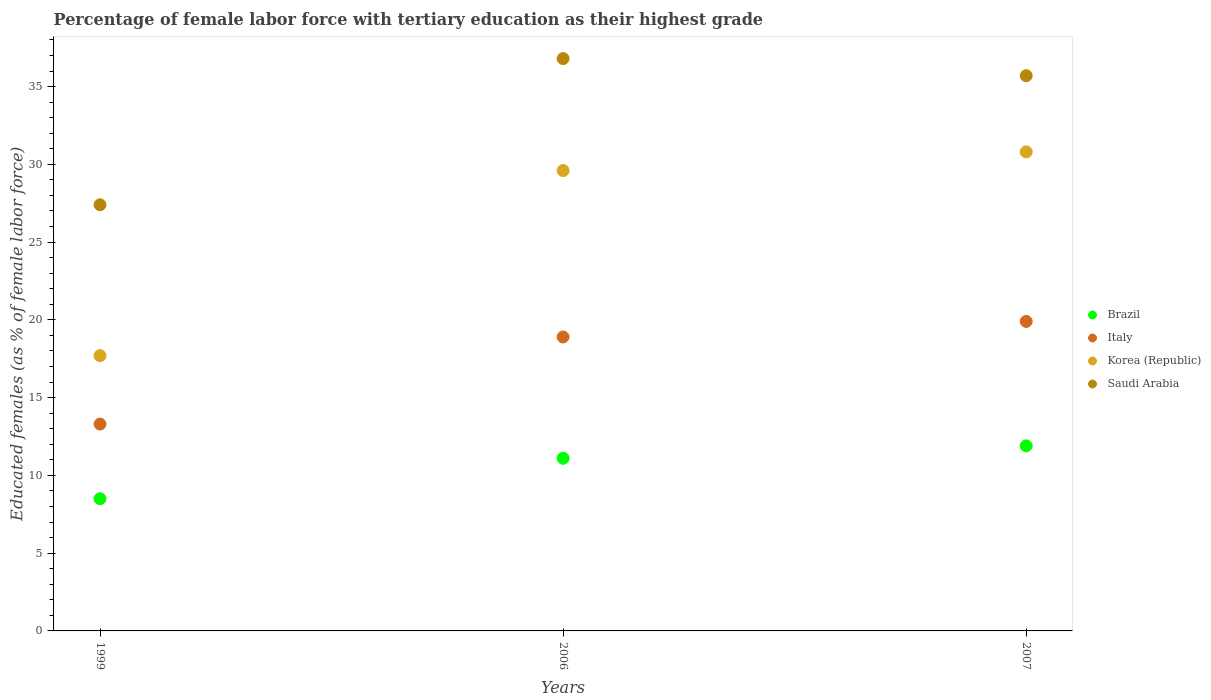How many different coloured dotlines are there?
Offer a terse response. 4. What is the percentage of female labor force with tertiary education in Korea (Republic) in 2007?
Keep it short and to the point. 30.8. Across all years, what is the maximum percentage of female labor force with tertiary education in Saudi Arabia?
Your answer should be compact. 36.8. Across all years, what is the minimum percentage of female labor force with tertiary education in Italy?
Offer a terse response. 13.3. In which year was the percentage of female labor force with tertiary education in Italy maximum?
Your response must be concise. 2007. In which year was the percentage of female labor force with tertiary education in Saudi Arabia minimum?
Offer a terse response. 1999. What is the total percentage of female labor force with tertiary education in Saudi Arabia in the graph?
Offer a very short reply. 99.9. What is the difference between the percentage of female labor force with tertiary education in Brazil in 1999 and that in 2007?
Provide a succinct answer. -3.4. What is the difference between the percentage of female labor force with tertiary education in Saudi Arabia in 1999 and the percentage of female labor force with tertiary education in Brazil in 2007?
Ensure brevity in your answer.  15.5. What is the average percentage of female labor force with tertiary education in Italy per year?
Provide a succinct answer. 17.37. In the year 2006, what is the difference between the percentage of female labor force with tertiary education in Korea (Republic) and percentage of female labor force with tertiary education in Brazil?
Provide a succinct answer. 18.5. In how many years, is the percentage of female labor force with tertiary education in Saudi Arabia greater than 4 %?
Keep it short and to the point. 3. What is the ratio of the percentage of female labor force with tertiary education in Italy in 2006 to that in 2007?
Offer a terse response. 0.95. Is the percentage of female labor force with tertiary education in Italy in 2006 less than that in 2007?
Your answer should be compact. Yes. What is the difference between the highest and the second highest percentage of female labor force with tertiary education in Saudi Arabia?
Ensure brevity in your answer.  1.1. What is the difference between the highest and the lowest percentage of female labor force with tertiary education in Korea (Republic)?
Provide a short and direct response. 13.1. In how many years, is the percentage of female labor force with tertiary education in Italy greater than the average percentage of female labor force with tertiary education in Italy taken over all years?
Your response must be concise. 2. Is the sum of the percentage of female labor force with tertiary education in Italy in 2006 and 2007 greater than the maximum percentage of female labor force with tertiary education in Saudi Arabia across all years?
Provide a succinct answer. Yes. Is it the case that in every year, the sum of the percentage of female labor force with tertiary education in Saudi Arabia and percentage of female labor force with tertiary education in Brazil  is greater than the sum of percentage of female labor force with tertiary education in Korea (Republic) and percentage of female labor force with tertiary education in Italy?
Give a very brief answer. Yes. Does the percentage of female labor force with tertiary education in Saudi Arabia monotonically increase over the years?
Keep it short and to the point. No. Is the percentage of female labor force with tertiary education in Korea (Republic) strictly greater than the percentage of female labor force with tertiary education in Saudi Arabia over the years?
Keep it short and to the point. No. Is the percentage of female labor force with tertiary education in Korea (Republic) strictly less than the percentage of female labor force with tertiary education in Italy over the years?
Your response must be concise. No. What is the title of the graph?
Your response must be concise. Percentage of female labor force with tertiary education as their highest grade. What is the label or title of the Y-axis?
Offer a terse response. Educated females (as % of female labor force). What is the Educated females (as % of female labor force) of Italy in 1999?
Keep it short and to the point. 13.3. What is the Educated females (as % of female labor force) in Korea (Republic) in 1999?
Provide a succinct answer. 17.7. What is the Educated females (as % of female labor force) of Saudi Arabia in 1999?
Provide a short and direct response. 27.4. What is the Educated females (as % of female labor force) in Brazil in 2006?
Your answer should be compact. 11.1. What is the Educated females (as % of female labor force) of Italy in 2006?
Provide a succinct answer. 18.9. What is the Educated females (as % of female labor force) in Korea (Republic) in 2006?
Provide a short and direct response. 29.6. What is the Educated females (as % of female labor force) in Saudi Arabia in 2006?
Your answer should be compact. 36.8. What is the Educated females (as % of female labor force) in Brazil in 2007?
Offer a terse response. 11.9. What is the Educated females (as % of female labor force) of Italy in 2007?
Ensure brevity in your answer.  19.9. What is the Educated females (as % of female labor force) in Korea (Republic) in 2007?
Give a very brief answer. 30.8. What is the Educated females (as % of female labor force) of Saudi Arabia in 2007?
Offer a terse response. 35.7. Across all years, what is the maximum Educated females (as % of female labor force) of Brazil?
Your answer should be very brief. 11.9. Across all years, what is the maximum Educated females (as % of female labor force) of Italy?
Offer a very short reply. 19.9. Across all years, what is the maximum Educated females (as % of female labor force) in Korea (Republic)?
Keep it short and to the point. 30.8. Across all years, what is the maximum Educated females (as % of female labor force) of Saudi Arabia?
Your answer should be very brief. 36.8. Across all years, what is the minimum Educated females (as % of female labor force) in Brazil?
Make the answer very short. 8.5. Across all years, what is the minimum Educated females (as % of female labor force) in Italy?
Provide a succinct answer. 13.3. Across all years, what is the minimum Educated females (as % of female labor force) of Korea (Republic)?
Make the answer very short. 17.7. Across all years, what is the minimum Educated females (as % of female labor force) of Saudi Arabia?
Your response must be concise. 27.4. What is the total Educated females (as % of female labor force) of Brazil in the graph?
Your answer should be very brief. 31.5. What is the total Educated females (as % of female labor force) in Italy in the graph?
Keep it short and to the point. 52.1. What is the total Educated females (as % of female labor force) of Korea (Republic) in the graph?
Ensure brevity in your answer.  78.1. What is the total Educated females (as % of female labor force) in Saudi Arabia in the graph?
Provide a succinct answer. 99.9. What is the difference between the Educated females (as % of female labor force) in Italy in 1999 and that in 2006?
Give a very brief answer. -5.6. What is the difference between the Educated females (as % of female labor force) of Saudi Arabia in 1999 and that in 2006?
Ensure brevity in your answer.  -9.4. What is the difference between the Educated females (as % of female labor force) in Brazil in 1999 and that in 2007?
Your answer should be compact. -3.4. What is the difference between the Educated females (as % of female labor force) in Korea (Republic) in 1999 and that in 2007?
Your response must be concise. -13.1. What is the difference between the Educated females (as % of female labor force) of Saudi Arabia in 2006 and that in 2007?
Offer a terse response. 1.1. What is the difference between the Educated females (as % of female labor force) in Brazil in 1999 and the Educated females (as % of female labor force) in Korea (Republic) in 2006?
Your answer should be very brief. -21.1. What is the difference between the Educated females (as % of female labor force) of Brazil in 1999 and the Educated females (as % of female labor force) of Saudi Arabia in 2006?
Offer a very short reply. -28.3. What is the difference between the Educated females (as % of female labor force) of Italy in 1999 and the Educated females (as % of female labor force) of Korea (Republic) in 2006?
Provide a short and direct response. -16.3. What is the difference between the Educated females (as % of female labor force) in Italy in 1999 and the Educated females (as % of female labor force) in Saudi Arabia in 2006?
Make the answer very short. -23.5. What is the difference between the Educated females (as % of female labor force) in Korea (Republic) in 1999 and the Educated females (as % of female labor force) in Saudi Arabia in 2006?
Give a very brief answer. -19.1. What is the difference between the Educated females (as % of female labor force) of Brazil in 1999 and the Educated females (as % of female labor force) of Korea (Republic) in 2007?
Give a very brief answer. -22.3. What is the difference between the Educated females (as % of female labor force) of Brazil in 1999 and the Educated females (as % of female labor force) of Saudi Arabia in 2007?
Offer a very short reply. -27.2. What is the difference between the Educated females (as % of female labor force) of Italy in 1999 and the Educated females (as % of female labor force) of Korea (Republic) in 2007?
Make the answer very short. -17.5. What is the difference between the Educated females (as % of female labor force) in Italy in 1999 and the Educated females (as % of female labor force) in Saudi Arabia in 2007?
Ensure brevity in your answer.  -22.4. What is the difference between the Educated females (as % of female labor force) of Brazil in 2006 and the Educated females (as % of female labor force) of Korea (Republic) in 2007?
Your response must be concise. -19.7. What is the difference between the Educated females (as % of female labor force) of Brazil in 2006 and the Educated females (as % of female labor force) of Saudi Arabia in 2007?
Provide a succinct answer. -24.6. What is the difference between the Educated females (as % of female labor force) in Italy in 2006 and the Educated females (as % of female labor force) in Saudi Arabia in 2007?
Provide a succinct answer. -16.8. What is the average Educated females (as % of female labor force) of Brazil per year?
Keep it short and to the point. 10.5. What is the average Educated females (as % of female labor force) in Italy per year?
Give a very brief answer. 17.37. What is the average Educated females (as % of female labor force) of Korea (Republic) per year?
Provide a short and direct response. 26.03. What is the average Educated females (as % of female labor force) of Saudi Arabia per year?
Offer a very short reply. 33.3. In the year 1999, what is the difference between the Educated females (as % of female labor force) in Brazil and Educated females (as % of female labor force) in Korea (Republic)?
Your answer should be compact. -9.2. In the year 1999, what is the difference between the Educated females (as % of female labor force) of Brazil and Educated females (as % of female labor force) of Saudi Arabia?
Keep it short and to the point. -18.9. In the year 1999, what is the difference between the Educated females (as % of female labor force) in Italy and Educated females (as % of female labor force) in Korea (Republic)?
Make the answer very short. -4.4. In the year 1999, what is the difference between the Educated females (as % of female labor force) of Italy and Educated females (as % of female labor force) of Saudi Arabia?
Offer a very short reply. -14.1. In the year 1999, what is the difference between the Educated females (as % of female labor force) of Korea (Republic) and Educated females (as % of female labor force) of Saudi Arabia?
Keep it short and to the point. -9.7. In the year 2006, what is the difference between the Educated females (as % of female labor force) in Brazil and Educated females (as % of female labor force) in Korea (Republic)?
Your response must be concise. -18.5. In the year 2006, what is the difference between the Educated females (as % of female labor force) of Brazil and Educated females (as % of female labor force) of Saudi Arabia?
Offer a terse response. -25.7. In the year 2006, what is the difference between the Educated females (as % of female labor force) of Italy and Educated females (as % of female labor force) of Korea (Republic)?
Your answer should be very brief. -10.7. In the year 2006, what is the difference between the Educated females (as % of female labor force) in Italy and Educated females (as % of female labor force) in Saudi Arabia?
Keep it short and to the point. -17.9. In the year 2006, what is the difference between the Educated females (as % of female labor force) in Korea (Republic) and Educated females (as % of female labor force) in Saudi Arabia?
Your response must be concise. -7.2. In the year 2007, what is the difference between the Educated females (as % of female labor force) in Brazil and Educated females (as % of female labor force) in Italy?
Offer a very short reply. -8. In the year 2007, what is the difference between the Educated females (as % of female labor force) of Brazil and Educated females (as % of female labor force) of Korea (Republic)?
Your response must be concise. -18.9. In the year 2007, what is the difference between the Educated females (as % of female labor force) in Brazil and Educated females (as % of female labor force) in Saudi Arabia?
Provide a succinct answer. -23.8. In the year 2007, what is the difference between the Educated females (as % of female labor force) of Italy and Educated females (as % of female labor force) of Saudi Arabia?
Provide a short and direct response. -15.8. What is the ratio of the Educated females (as % of female labor force) of Brazil in 1999 to that in 2006?
Give a very brief answer. 0.77. What is the ratio of the Educated females (as % of female labor force) in Italy in 1999 to that in 2006?
Make the answer very short. 0.7. What is the ratio of the Educated females (as % of female labor force) in Korea (Republic) in 1999 to that in 2006?
Provide a succinct answer. 0.6. What is the ratio of the Educated females (as % of female labor force) of Saudi Arabia in 1999 to that in 2006?
Keep it short and to the point. 0.74. What is the ratio of the Educated females (as % of female labor force) of Italy in 1999 to that in 2007?
Offer a very short reply. 0.67. What is the ratio of the Educated females (as % of female labor force) of Korea (Republic) in 1999 to that in 2007?
Your answer should be very brief. 0.57. What is the ratio of the Educated females (as % of female labor force) of Saudi Arabia in 1999 to that in 2007?
Ensure brevity in your answer.  0.77. What is the ratio of the Educated females (as % of female labor force) in Brazil in 2006 to that in 2007?
Give a very brief answer. 0.93. What is the ratio of the Educated females (as % of female labor force) in Italy in 2006 to that in 2007?
Your answer should be compact. 0.95. What is the ratio of the Educated females (as % of female labor force) in Korea (Republic) in 2006 to that in 2007?
Provide a succinct answer. 0.96. What is the ratio of the Educated females (as % of female labor force) in Saudi Arabia in 2006 to that in 2007?
Keep it short and to the point. 1.03. What is the difference between the highest and the second highest Educated females (as % of female labor force) of Brazil?
Keep it short and to the point. 0.8. What is the difference between the highest and the second highest Educated females (as % of female labor force) of Korea (Republic)?
Offer a terse response. 1.2. What is the difference between the highest and the second highest Educated females (as % of female labor force) of Saudi Arabia?
Provide a short and direct response. 1.1. What is the difference between the highest and the lowest Educated females (as % of female labor force) of Brazil?
Offer a very short reply. 3.4. What is the difference between the highest and the lowest Educated females (as % of female labor force) in Korea (Republic)?
Ensure brevity in your answer.  13.1. What is the difference between the highest and the lowest Educated females (as % of female labor force) in Saudi Arabia?
Your answer should be compact. 9.4. 